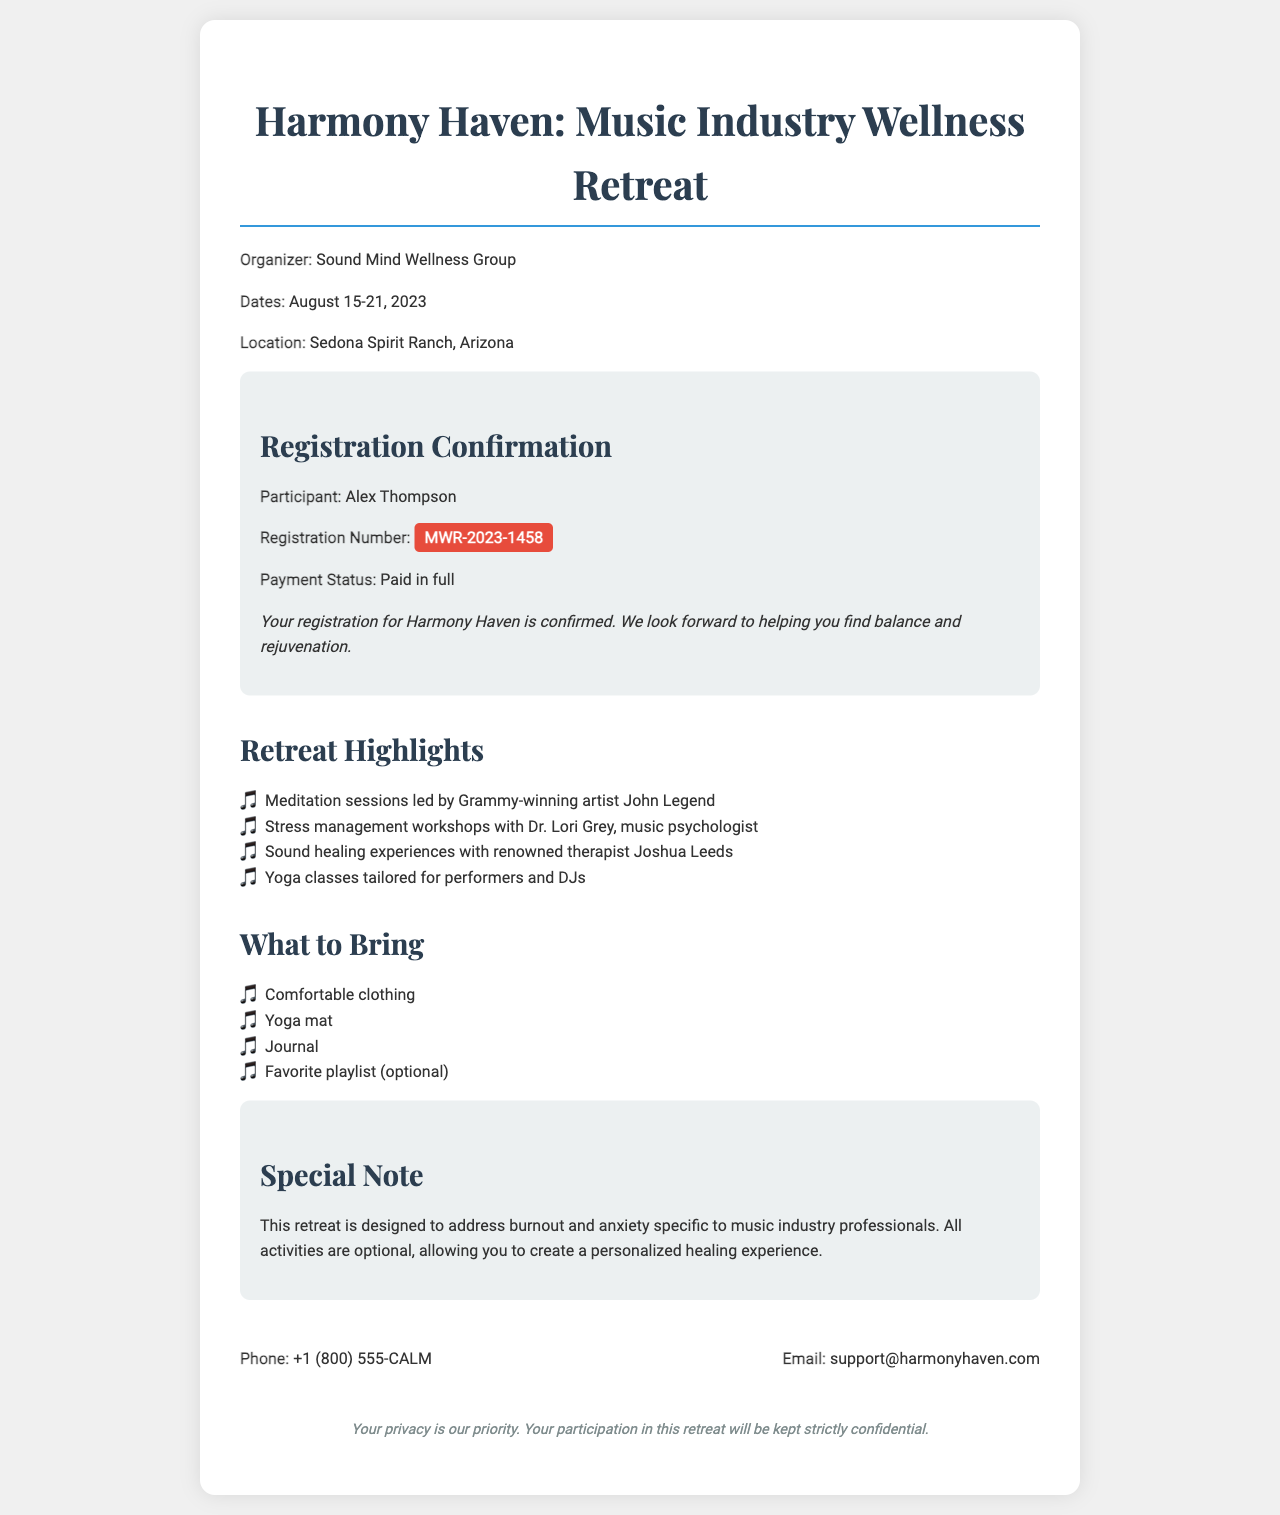What is the name of the organizer? The organizer's name is mentioned in the document as "Sound Mind Wellness Group."
Answer: Sound Mind Wellness Group What are the dates of the retreat? The document specifies the retreat dates as "August 15-21, 2023."
Answer: August 15-21, 2023 What is the registration number? The registration number provided in the document is "MWR-2023-1458."
Answer: MWR-2023-1458 Who is the participant? The participant's name listed in the document is "Alex Thompson."
Answer: Alex Thompson What is the payment status? The document states that the payment status is "Paid in full."
Answer: Paid in full What is a notable activity mentioned in the retreat highlights? The document lists meditation sessions led by a Grammy-winning artist, specifically John Legend, as a notable activity.
Answer: Meditation sessions led by John Legend What should participants bring? The document suggests bringing a "Yoga mat" as one of the items.
Answer: Yoga mat What is the main purpose of the retreat? The document indicates that the retreat is designed to address "burnout and anxiety specific to music industry professionals."
Answer: Burnout and anxiety What is the contact phone number? The document provides the contact phone number as "+1 (800) 555-CALM."
Answer: +1 (800) 555-CALM 